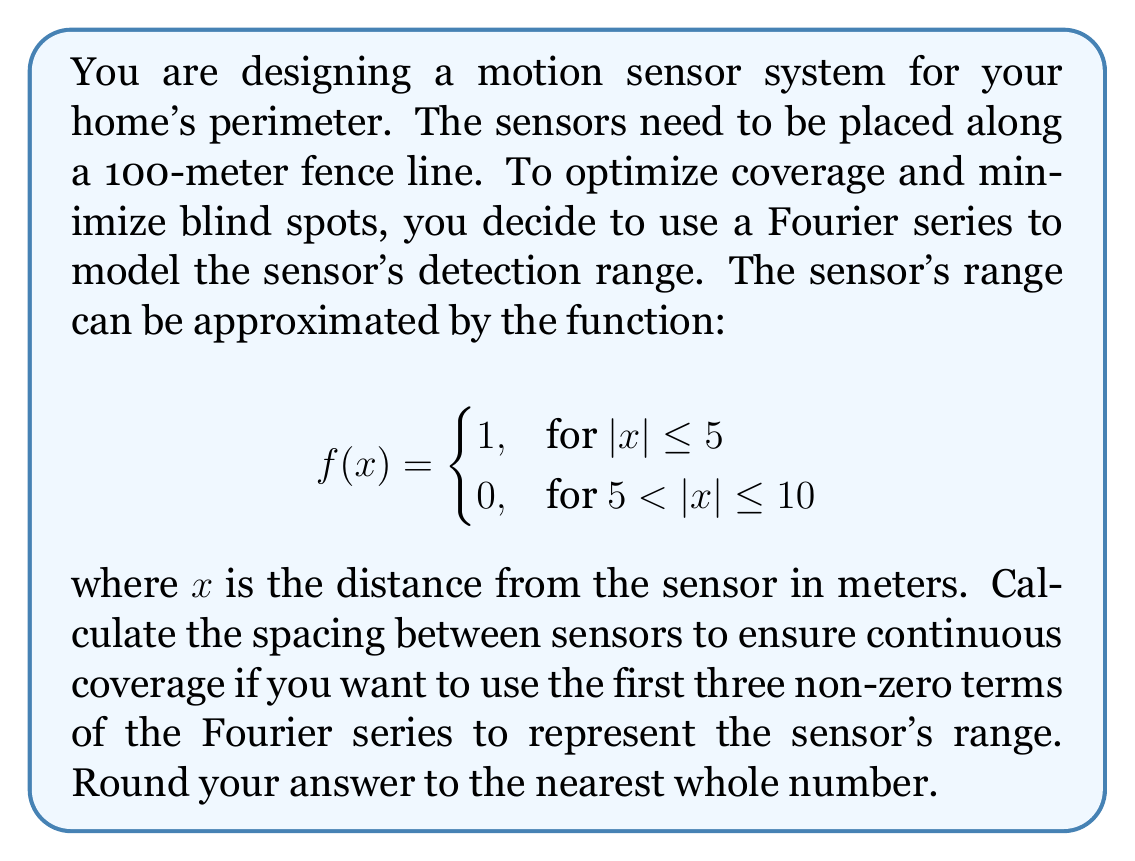Can you answer this question? To solve this problem, we need to follow these steps:

1) First, we need to find the Fourier series representation of the given function. The Fourier series for an even function on the interval $[-L, L]$ is given by:

   $$f(x) = \frac{a_0}{2} + \sum_{n=1}^{\infty} a_n \cos(\frac{n\pi x}{L})$$

   where $a_n = \frac{1}{L}\int_{-L}^{L} f(x)\cos(\frac{n\pi x}{L})dx$

2) In our case, $L = 10$ (half the period of the function). We need to calculate $a_0$, $a_1$, and $a_3$ (as $a_2$ will be zero due to the symmetry of the function).

3) Calculating $a_0$:
   $$a_0 = \frac{1}{10}\int_{-10}^{10} f(x)dx = \frac{1}{10}(2\cdot5) = 1$$

4) Calculating $a_1$:
   $$a_1 = \frac{1}{10}\int_{-5}^{5} \cos(\frac{\pi x}{10})dx = \frac{20}{\pi}\sin(\frac{\pi}{2}) = \frac{20}{\pi}$$

5) Calculating $a_3$:
   $$a_3 = \frac{1}{10}\int_{-5}^{5} \cos(\frac{3\pi x}{10})dx = \frac{20}{3\pi}\sin(\frac{3\pi}{2}) = -\frac{20}{3\pi}$$

6) Therefore, the first three non-zero terms of the Fourier series are:

   $$f(x) \approx \frac{1}{2} + \frac{20}{\pi}\cos(\frac{\pi x}{10}) - \frac{20}{3\pi}\cos(\frac{3\pi x}{10})$$

7) To ensure continuous coverage, we need to place the sensors where the function reaches its first zero. This occurs when:

   $$\frac{1}{2} + \frac{20}{\pi}\cos(\frac{\pi x}{10}) - \frac{20}{3\pi}\cos(\frac{3\pi x}{10}) = 0$$

8) Solving this equation numerically (as it's transcendental), we find that the first zero occurs at approximately $x \approx 9.42$ meters.

9) Therefore, the spacing between sensors should be twice this distance: $2 * 9.42 \approx 18.84$ meters.

10) Rounding to the nearest whole number gives us 19 meters.
Answer: The optimal spacing between motion sensors is 19 meters. 